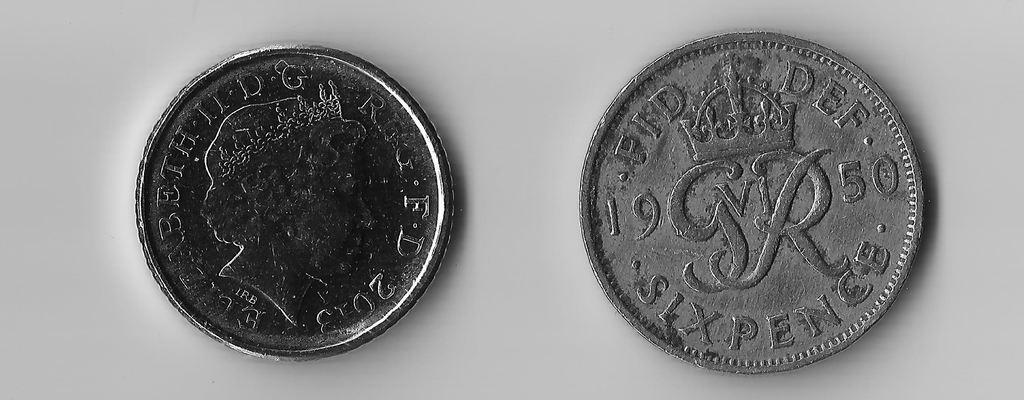In what year is the coin on the right minted?
Keep it short and to the point. 1950. What monetary value is the right coin?
Provide a succinct answer. Six pence. 